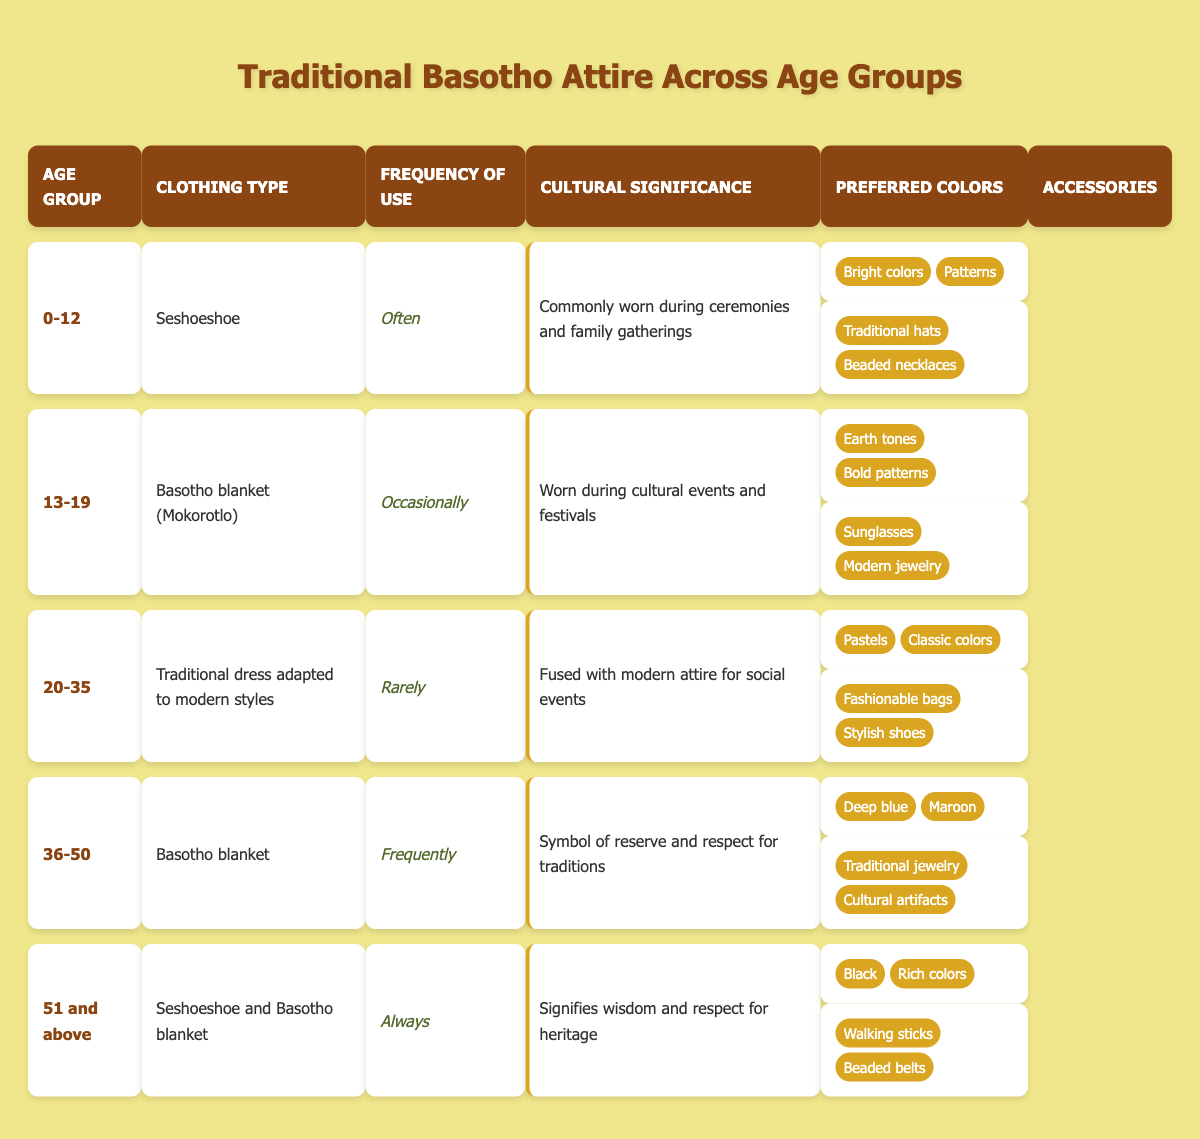What clothing type is most commonly worn by those aged 0-12? According to the table, the clothing type frequently worn by the 0-12 age group is "Seshoeshoe."
Answer: Seshoeshoe How frequently do individuals aged 20-35 use traditional Basotho attire? The table indicates that individuals aged 20-35 use traditional attire "Rarely."
Answer: Rarely Which age group has the highest frequency of traditional attire usage? The table shows that the age group "51 and above" uses traditional attire "Always," which is the highest frequency of use compared to other groups.
Answer: 51 and above What cultural significance is attributed to the Basotho blanket worn by the 36-50 age group? The table states that for the 36-50 age group, the Basotho blanket is a "Symbol of reserve and respect for traditions."
Answer: Symbol of reserve and respect for traditions Are sunglasses listed as an accessory for the 0-12 age group? The table does not list sunglasses as an accessory for the 0-12 age group; instead, it lists "Traditional hats" and "Beaded necklaces." Therefore, the statement is false.
Answer: False What is the most common accessory for individuals aged 51 and above? The table lists "Walking sticks" and "Beaded belts" as accessories for the 51 and above age group. Since there are two, it can be concluded that both are common.
Answer: Walking sticks and Beaded belts Is there any age group that uses traditional attire more frequently than "Frequently"? The table shows that "Always" is the most frequent use, which only applies to the 51 and above age group. Hence, no age group uses traditional attire more frequently than that.
Answer: No How does the frequency of use for "Seshoeshoe" differ between ages 0-12 and 51 and above? The frequency of use for Seshoeshoe in ages 0-12 is "Often," while for 51 and above, it is part of the attire used "Always." This indicates a progression in frequency from 0-12 to 51 and above.
Answer: Progression from "Often" to "Always" What are the preferred colors for those aged 13-19? The table lists the preferred colors for the 13-19 age group as "Earth tones" and "Bold patterns."
Answer: Earth tones and Bold patterns Calculate the difference in frequency of use between the 36-50 age group and the 20-35 age group. The 36-50 age group uses attire "Frequently," while the 20-35 age group uses it "Rarely." The difference in frequency is from "Frequently" to "Rarely," indicating a step down in frequency.
Answer: From "Frequently" to "Rarely" (difference) How many different types of attire are listed in the table? The table lists five different clothing types corresponding to each age group: Seshoeshoe, Basotho blanket (Mokorotlo), Traditional dress adapted to modern styles, Basotho blanket, and Seshoeshoe and Basotho blanket. Counting these, we find there are five.
Answer: Five types of attire 